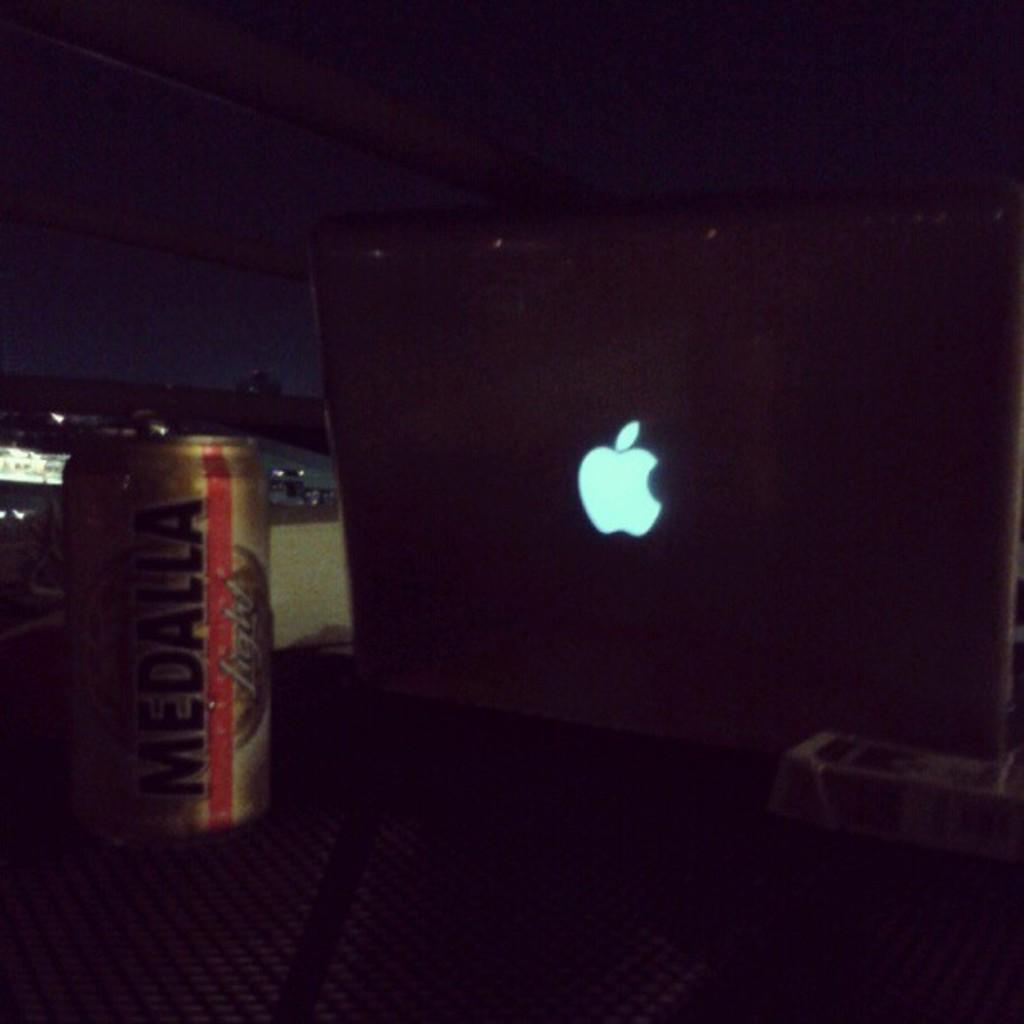<image>
Provide a brief description of the given image. an apple logo next to a beer with the letter A on it 